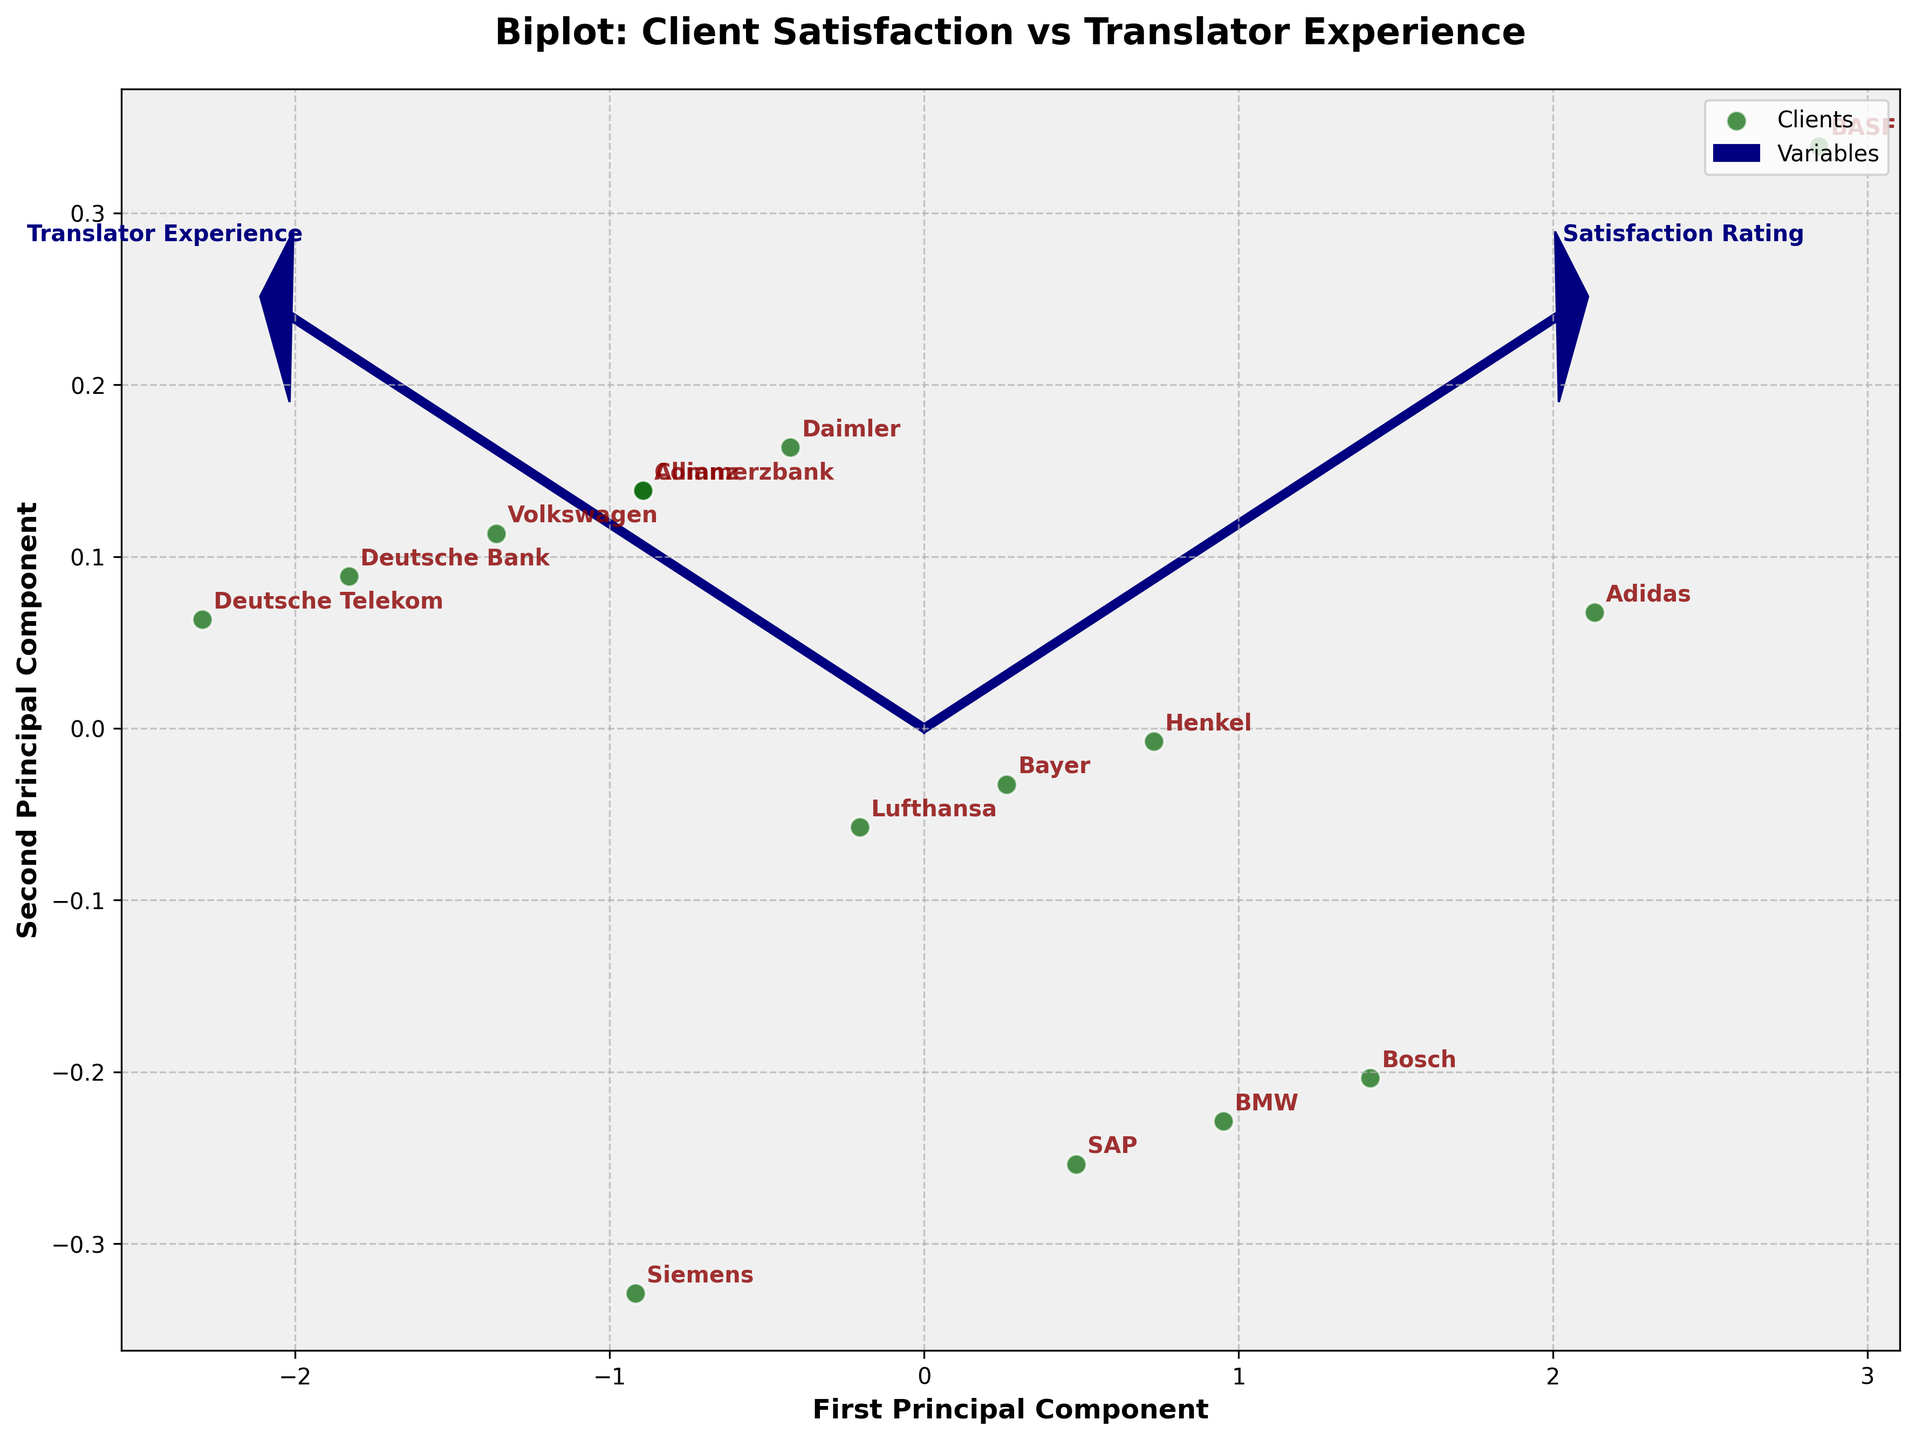What is the title of the figure? The title of the figure is displayed at the top and provides a brief description of what the plot represents. It reads "Biplot: Client Satisfaction vs Translator Experience".
Answer: Biplot: Client Satisfaction vs Translator Experience How many clients are plotted in the figure? The number of data points in the plot each represent a client. Counting these points gives the answer.
Answer: 15 Which vector represents the "Satisfaction Rating"? In a biplot, vectors represent the variables. The vector labeled "Satisfaction Rating" represents the Satisfaction Rating variable. It is one of the two arrows emanating from the origin.
Answer: The vector labeled "Satisfaction Rating" Which client has the highest Translator Experience according to the plot? By examining the labels associated with the data points, we identify the client positioned farthest along the Translator Experience axis. BASF is farthest in the direction of the Translator Experience vector.
Answer: BASF What is the relationship between Satisfaction Rating and Translator Experience? By looking at the angles between the vectors in the biplot, we can determine the relationship. Since the vectors are not perpendicular and appear to point in roughly similar directions, this indicates a positive correlation between the two variables.
Answer: Positive correlation Which clients have a Translator Experience of 5 years? By locating the points that align with 5 years on the Translator Experience vector and reading off the labels for these points. Lufthansa and Daimler both align with this experience level.
Answer: Lufthansa and Daimler Where is Deutsche Telekom positioned in the biplot? Deutsche Telekom is the point near the origin and is identified by its label in the plot. Based on the plot, it is positioned closest to the smallest values of both principal components.
Answer: Near the origin, closest to both PCs Compare the Satisfaction Rating of Adidas and Bosch. Which one is higher? By looking at the separation and direction of these two points along the Satisfaction Rating vector, we can assess their relative satisfaction ratings. Adidas is positioned further along the Satisfaction Rating vector.
Answer: Adidas What is the significance of the length of the vectors in a biplot? The length of the vectors indicates the relative importance or contribution of that variable to the principal components. Longer vectors suggest a greater influence on the data structure in the biplot.
Answer: Vectors' lengths indicate variable importance How is the initial data transformed in order to be represented in the biplot? The data is standardized, a covariance matrix is calculated, eigenvalues and eigenvectors are derived, and then data is projected onto the principal components. These steps transform the data to be represented in the biplot.
Answer: Standardized and projected onto principal components 